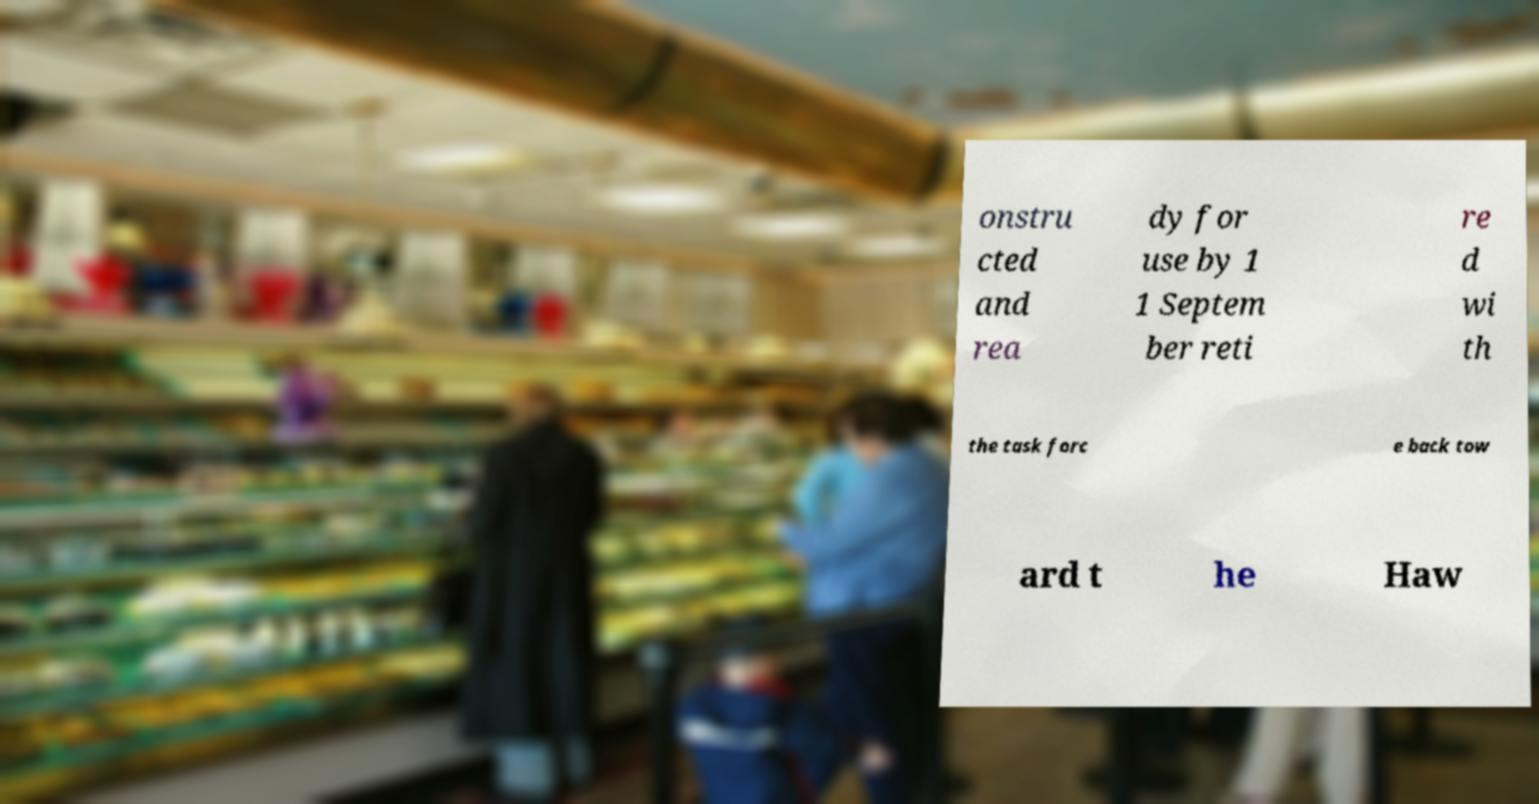Could you assist in decoding the text presented in this image and type it out clearly? onstru cted and rea dy for use by 1 1 Septem ber reti re d wi th the task forc e back tow ard t he Haw 